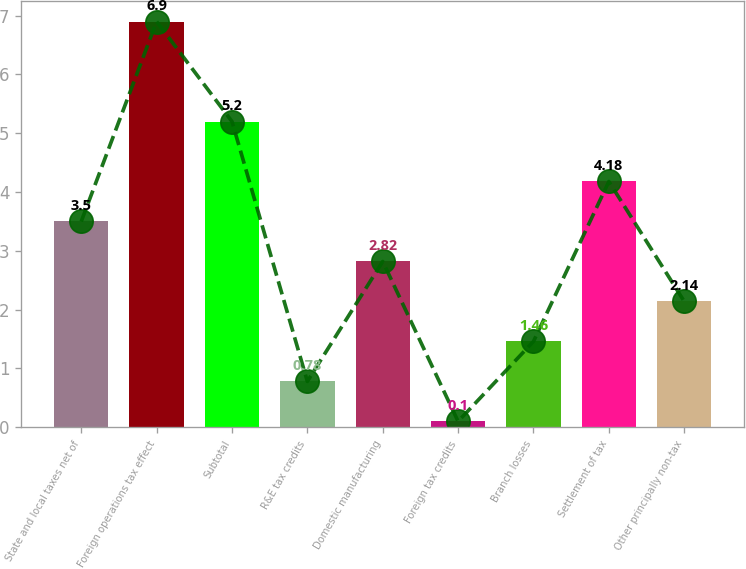Convert chart. <chart><loc_0><loc_0><loc_500><loc_500><bar_chart><fcel>State and local taxes net of<fcel>Foreign operations tax effect<fcel>Subtotal<fcel>R&E tax credits<fcel>Domestic manufacturing<fcel>Foreign tax credits<fcel>Branch losses<fcel>Settlement of tax<fcel>Other principally non-tax<nl><fcel>3.5<fcel>6.9<fcel>5.2<fcel>0.78<fcel>2.82<fcel>0.1<fcel>1.46<fcel>4.18<fcel>2.14<nl></chart> 